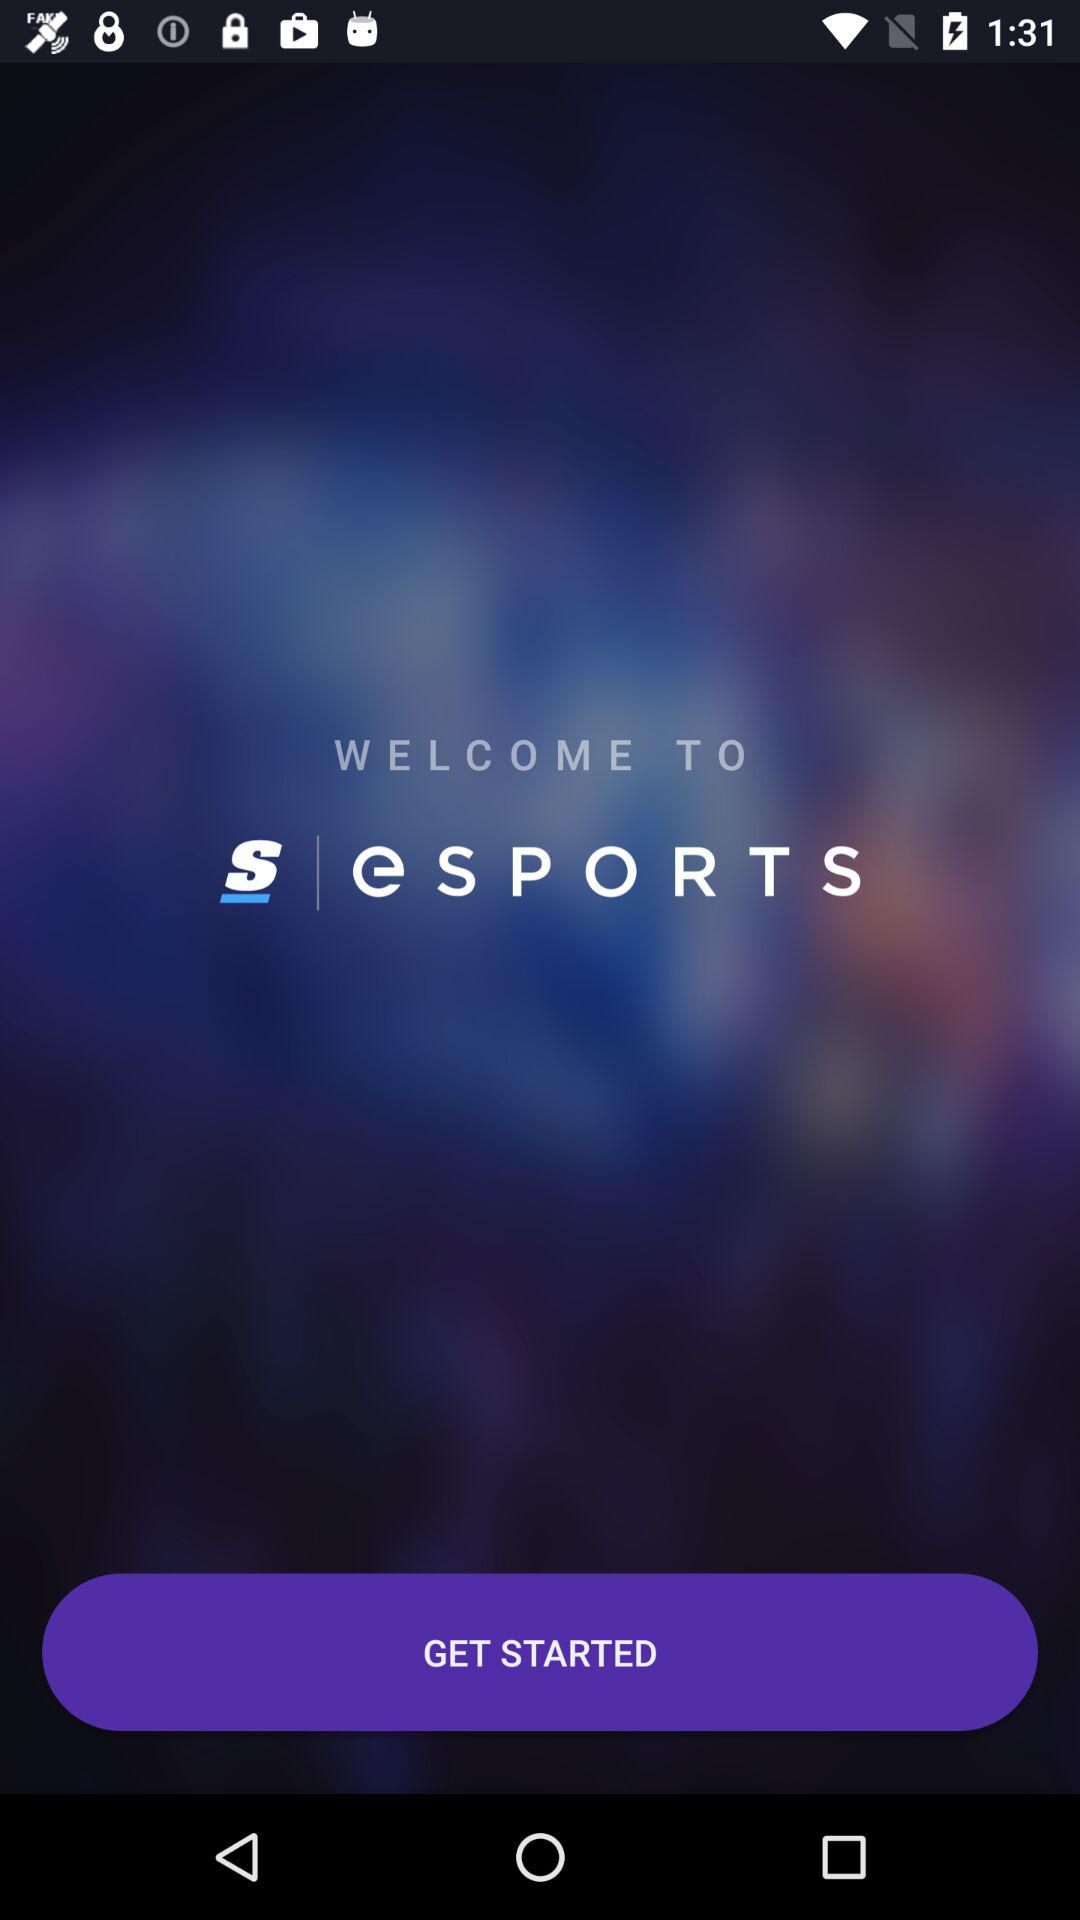What is the name of the application? The name of the application is "eSPORTS". 